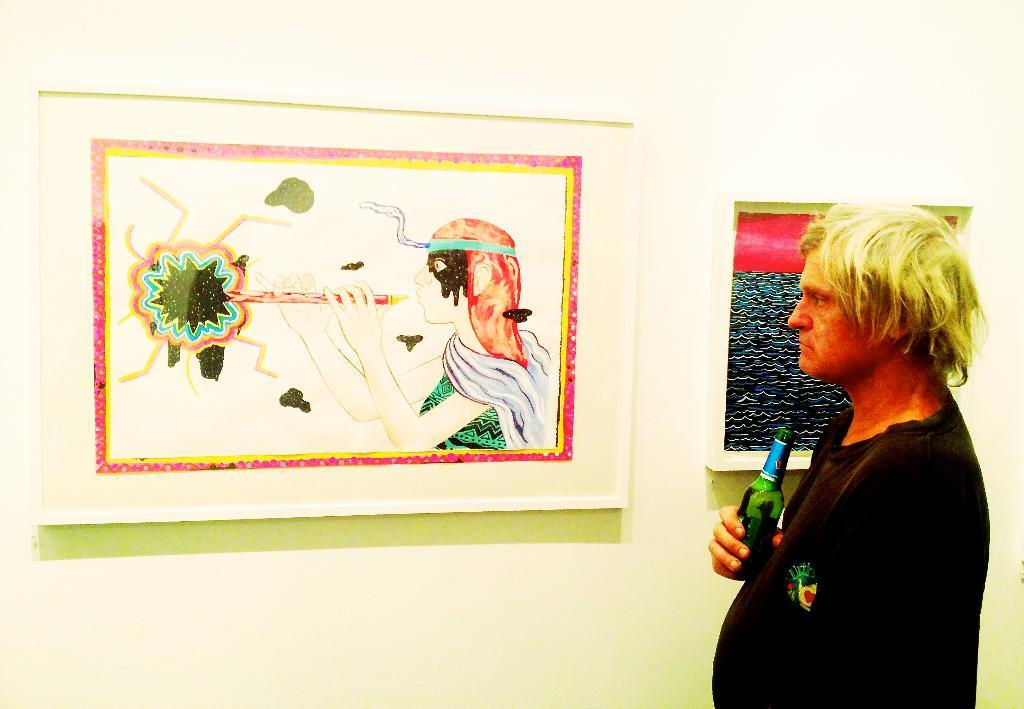Who is present in the image? There is a guy in the picture. What is the guy holding in his hand? The guy is holding a bottle in one of his hands. What can be seen on the wall in the image? There is a picture mounted on the wall. What is the guy doing in the image? The guy is looking at the mounted picture. What type of minister is present in the image? There is no minister present in the image; it only features a guy holding a bottle and looking at a mounted picture. 